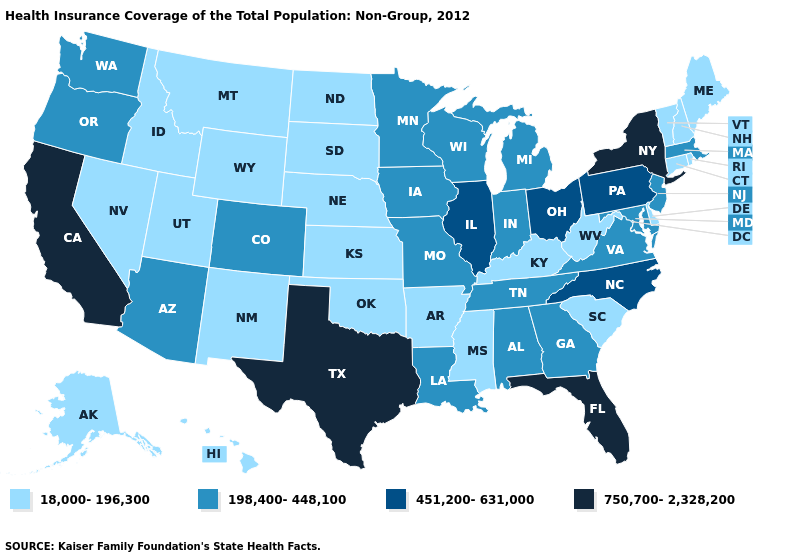Name the states that have a value in the range 750,700-2,328,200?
Keep it brief. California, Florida, New York, Texas. What is the value of New York?
Answer briefly. 750,700-2,328,200. How many symbols are there in the legend?
Be succinct. 4. Does Maine have the highest value in the Northeast?
Short answer required. No. What is the lowest value in states that border Nevada?
Give a very brief answer. 18,000-196,300. Is the legend a continuous bar?
Short answer required. No. Which states hav the highest value in the MidWest?
Answer briefly. Illinois, Ohio. Does the map have missing data?
Write a very short answer. No. Is the legend a continuous bar?
Answer briefly. No. Among the states that border Washington , does Idaho have the highest value?
Give a very brief answer. No. Which states have the highest value in the USA?
Be succinct. California, Florida, New York, Texas. What is the value of Missouri?
Keep it brief. 198,400-448,100. How many symbols are there in the legend?
Concise answer only. 4. Does Idaho have a lower value than Washington?
Write a very short answer. Yes. Name the states that have a value in the range 18,000-196,300?
Answer briefly. Alaska, Arkansas, Connecticut, Delaware, Hawaii, Idaho, Kansas, Kentucky, Maine, Mississippi, Montana, Nebraska, Nevada, New Hampshire, New Mexico, North Dakota, Oklahoma, Rhode Island, South Carolina, South Dakota, Utah, Vermont, West Virginia, Wyoming. 